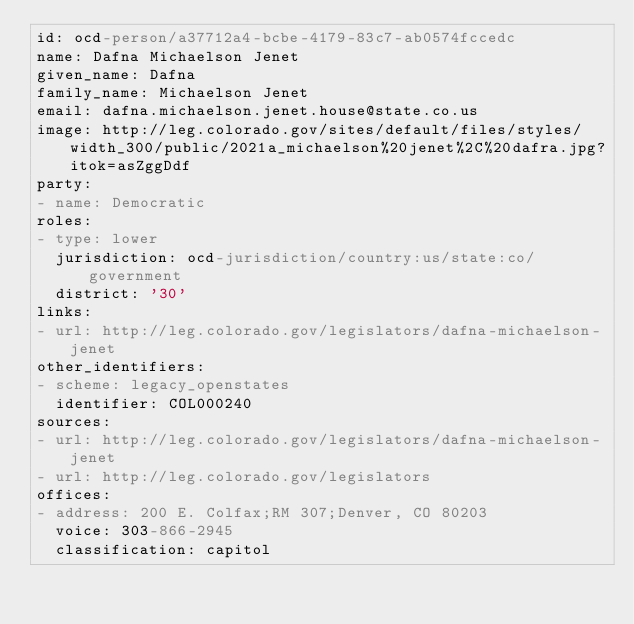Convert code to text. <code><loc_0><loc_0><loc_500><loc_500><_YAML_>id: ocd-person/a37712a4-bcbe-4179-83c7-ab0574fccedc
name: Dafna Michaelson Jenet
given_name: Dafna
family_name: Michaelson Jenet
email: dafna.michaelson.jenet.house@state.co.us
image: http://leg.colorado.gov/sites/default/files/styles/width_300/public/2021a_michaelson%20jenet%2C%20dafra.jpg?itok=asZggDdf
party:
- name: Democratic
roles:
- type: lower
  jurisdiction: ocd-jurisdiction/country:us/state:co/government
  district: '30'
links:
- url: http://leg.colorado.gov/legislators/dafna-michaelson-jenet
other_identifiers:
- scheme: legacy_openstates
  identifier: COL000240
sources:
- url: http://leg.colorado.gov/legislators/dafna-michaelson-jenet
- url: http://leg.colorado.gov/legislators
offices:
- address: 200 E. Colfax;RM 307;Denver, CO 80203
  voice: 303-866-2945
  classification: capitol
</code> 